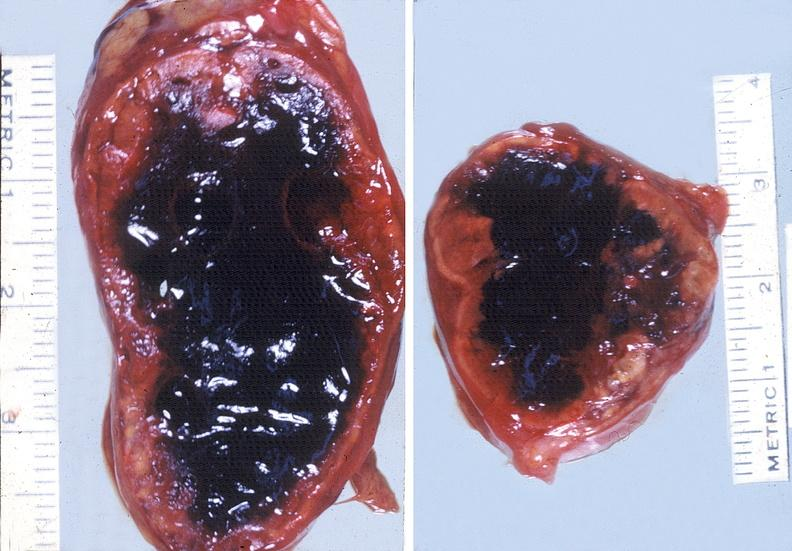does another fiber other frame show adrenal, hemorrhage?
Answer the question using a single word or phrase. No 